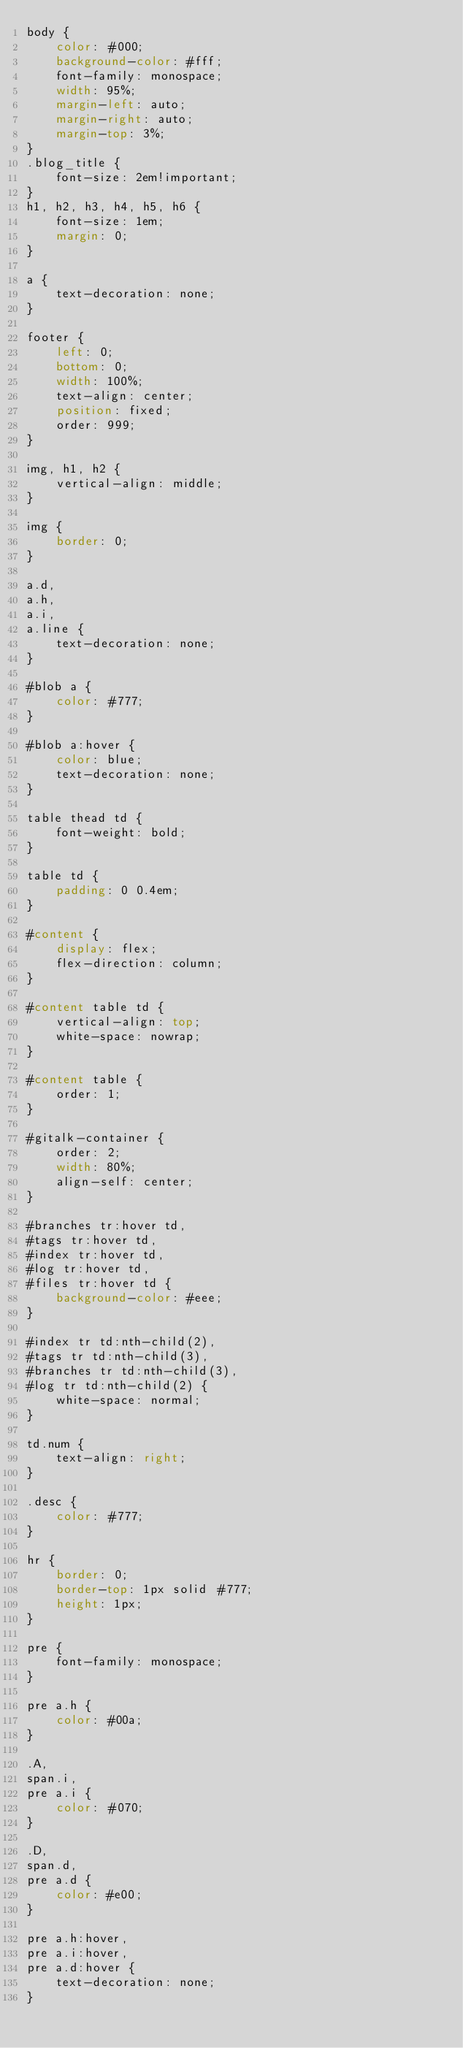Convert code to text. <code><loc_0><loc_0><loc_500><loc_500><_CSS_>body {
	color: #000;
	background-color: #fff;
	font-family: monospace;
	width: 95%;
	margin-left: auto;
	margin-right: auto;
	margin-top: 3%;
}
.blog_title {
	font-size: 2em!important;
}
h1, h2, h3, h4, h5, h6 {
	font-size: 1em;
	margin: 0;
}

a {
	text-decoration: none;
}

footer {
	left: 0;
	bottom: 0;
	width: 100%;
	text-align: center;
	position: fixed;
	order: 999;
}

img, h1, h2 {
	vertical-align: middle;
}

img {
	border: 0;
}

a.d,
a.h,
a.i,
a.line {
	text-decoration: none;
}

#blob a {
	color: #777;
}

#blob a:hover {
	color: blue;
	text-decoration: none;
}

table thead td {
	font-weight: bold;
}

table td {
	padding: 0 0.4em;
}

#content {
	display: flex;
	flex-direction: column;
}

#content table td {
	vertical-align: top;
	white-space: nowrap;
}

#content table {
	order: 1;
}

#gitalk-container {
	order: 2;
	width: 80%;
    align-self: center;
}

#branches tr:hover td,
#tags tr:hover td,
#index tr:hover td,
#log tr:hover td,
#files tr:hover td {
	background-color: #eee;
}

#index tr td:nth-child(2),
#tags tr td:nth-child(3),
#branches tr td:nth-child(3),
#log tr td:nth-child(2) {
	white-space: normal;
}

td.num {
	text-align: right;
}

.desc {
	color: #777;
}

hr {
	border: 0;
	border-top: 1px solid #777;
	height: 1px;
}

pre {
	font-family: monospace;
}

pre a.h {
	color: #00a;
}

.A,
span.i,
pre a.i {
	color: #070;
}

.D,
span.d,
pre a.d {
	color: #e00;
}

pre a.h:hover,
pre a.i:hover,
pre a.d:hover {
	text-decoration: none;
}

</code> 